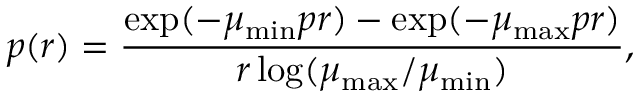<formula> <loc_0><loc_0><loc_500><loc_500>p ( r ) = \frac { \exp ( - \mu _ { \min } p r ) - \exp ( - \mu _ { \max } p r ) } { r \log ( \mu _ { \max } / \mu _ { \min } ) } ,</formula> 